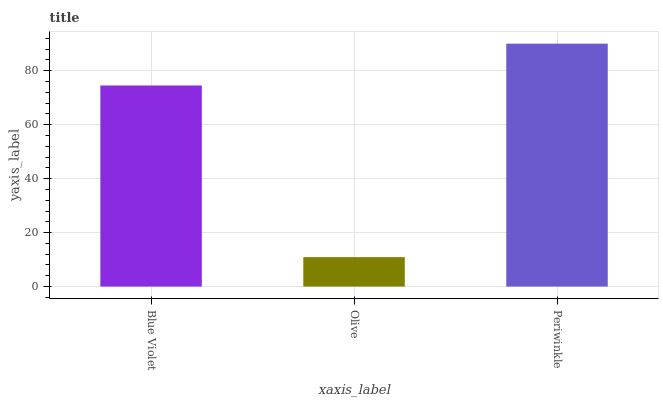Is Olive the minimum?
Answer yes or no. Yes. Is Periwinkle the maximum?
Answer yes or no. Yes. Is Periwinkle the minimum?
Answer yes or no. No. Is Olive the maximum?
Answer yes or no. No. Is Periwinkle greater than Olive?
Answer yes or no. Yes. Is Olive less than Periwinkle?
Answer yes or no. Yes. Is Olive greater than Periwinkle?
Answer yes or no. No. Is Periwinkle less than Olive?
Answer yes or no. No. Is Blue Violet the high median?
Answer yes or no. Yes. Is Blue Violet the low median?
Answer yes or no. Yes. Is Periwinkle the high median?
Answer yes or no. No. Is Periwinkle the low median?
Answer yes or no. No. 